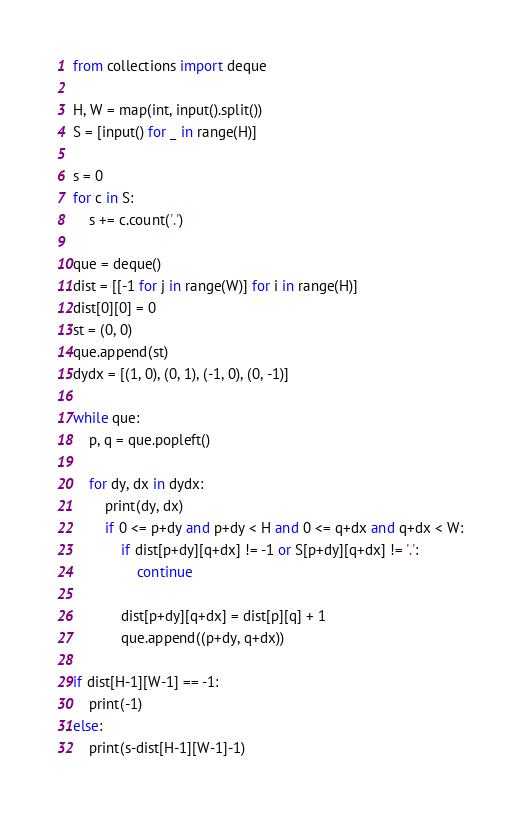<code> <loc_0><loc_0><loc_500><loc_500><_Python_>from collections import deque

H, W = map(int, input().split())
S = [input() for _ in range(H)]

s = 0
for c in S:
    s += c.count('.')

que = deque()
dist = [[-1 for j in range(W)] for i in range(H)]
dist[0][0] = 0
st = (0, 0)
que.append(st)
dydx = [(1, 0), (0, 1), (-1, 0), (0, -1)]

while que:
    p, q = que.popleft()

    for dy, dx in dydx:
        print(dy, dx)
        if 0 <= p+dy and p+dy < H and 0 <= q+dx and q+dx < W:
            if dist[p+dy][q+dx] != -1 or S[p+dy][q+dx] != '.':
                continue

            dist[p+dy][q+dx] = dist[p][q] + 1
            que.append((p+dy, q+dx))

if dist[H-1][W-1] == -1:
    print(-1)
else:
    print(s-dist[H-1][W-1]-1)</code> 